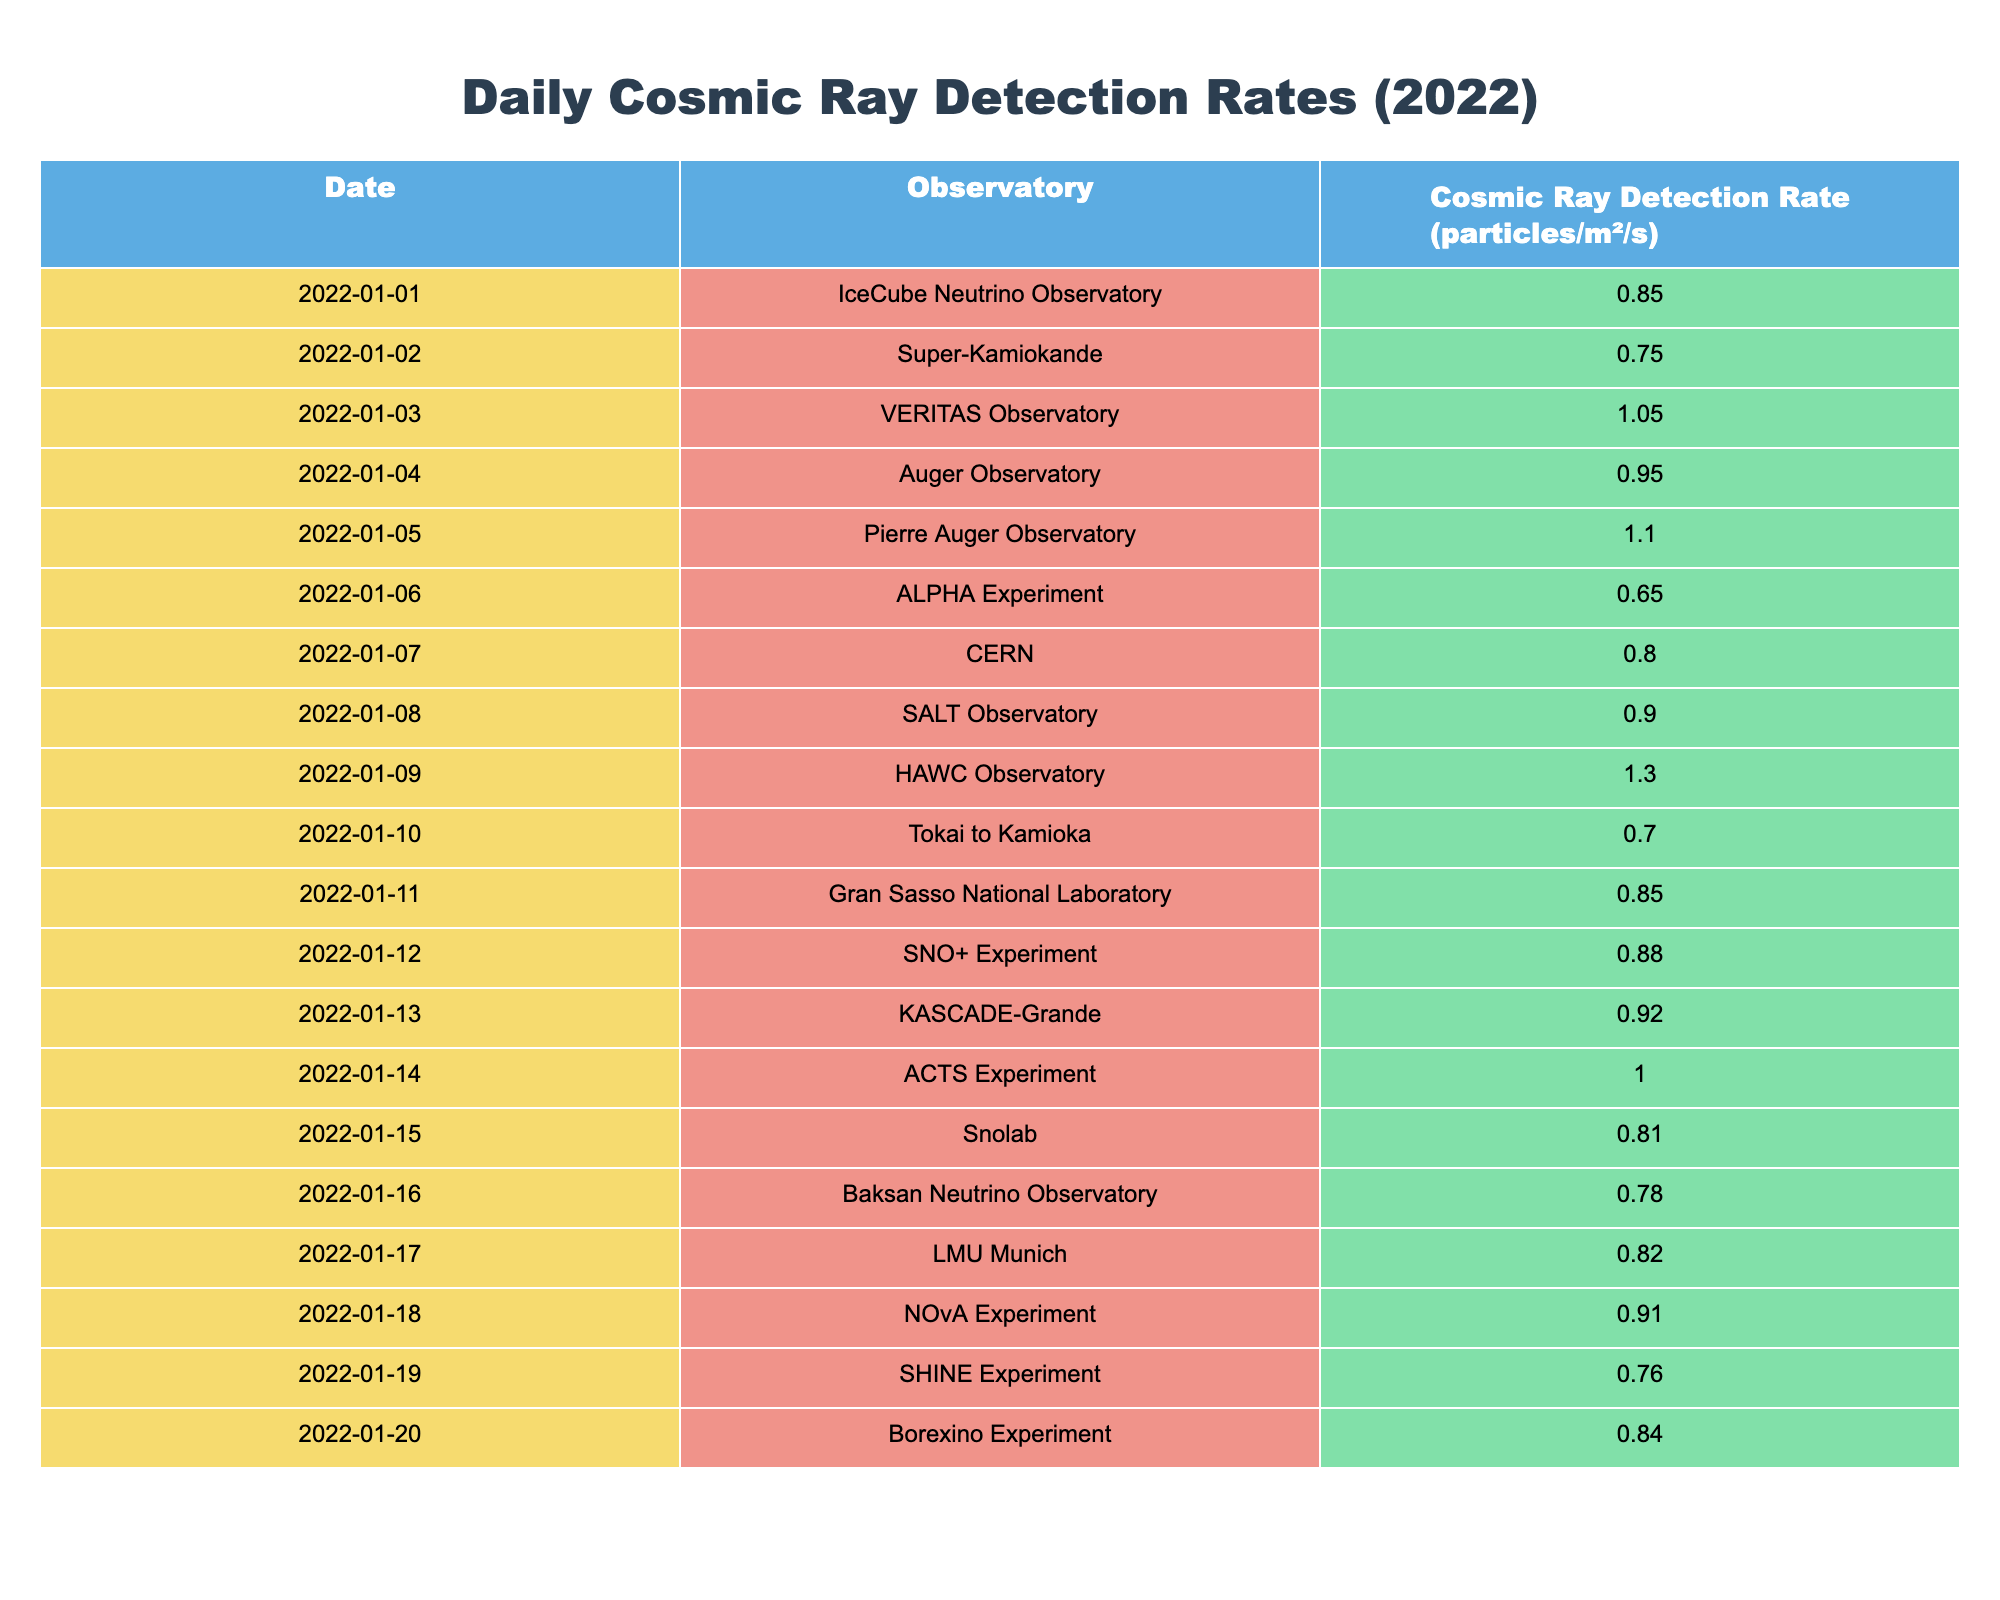What is the cosmic ray detection rate at the HAWC Observatory on January 9, 2022? From the table, the HAWC Observatory's cosmic ray detection rate is listed next to its date of January 9, 2022, which shows a rate of 1.30 particles/m²/s.
Answer: 1.30 Which observatory recorded the highest cosmic ray detection rate in 2022? By scanning through the table for the highest value, the HAWC Observatory on January 9, 2022, recorded the highest rate of 1.30 particles/m²/s.
Answer: HAWC Observatory What is the average cosmic ray detection rate from the Pierre Auger Observatory and Super-Kamiokande? The cosmic ray detection rates from the Pierre Auger Observatory and Super-Kamiokande are 1.10 and 0.75 particles/m²/s, respectively. First, we sum them up (1.10 + 0.75 = 1.85), then divide by 2 to find the average (1.85 / 2 = 0.925).
Answer: 0.925 Did the Baksan Neutrino Observatory have a detection rate higher than 0.80 on any of the listed dates? The table shows that the detection rate for the Baksan Neutrino Observatory on January 16, 2022, was 0.78 particles/m²/s, which is not higher than 0.80. Therefore, the answer is no.
Answer: No What is the total cosmic ray detection rate from all observatories on January 1 to January 5, 2022? We will add the cosmic ray detection rates for each of those five dates: on January 1 it was 0.85, January 2 was 0.75, January 3 was 1.05, January 4 was 0.95, and January 5 was 1.10. Summing these rates gives us: (0.85 + 0.75 + 1.05 + 0.95 + 1.10) = 4.70 particles/m²/s.
Answer: 4.70 